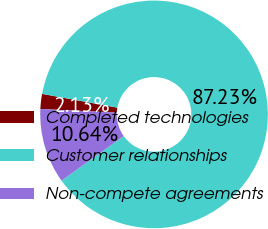Convert chart to OTSL. <chart><loc_0><loc_0><loc_500><loc_500><pie_chart><fcel>Completed technologies<fcel>Customer relationships<fcel>Non-compete agreements<nl><fcel>2.13%<fcel>87.23%<fcel>10.64%<nl></chart> 